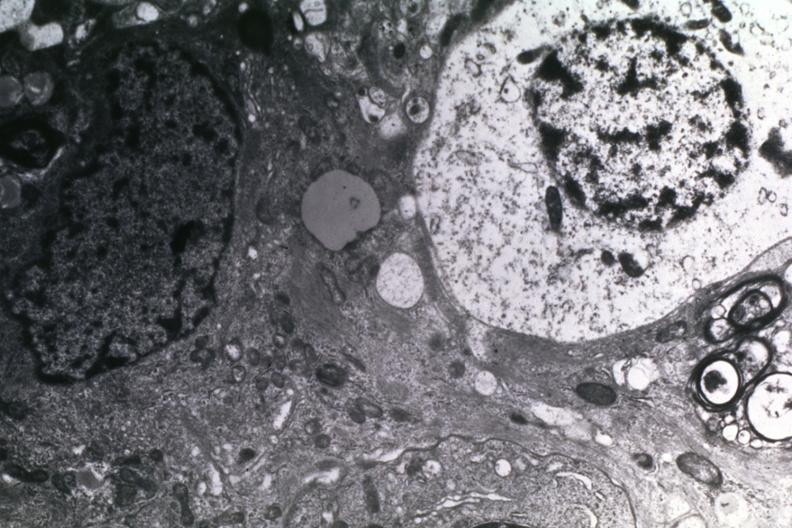s palmar crease normal present?
Answer the question using a single word or phrase. No 